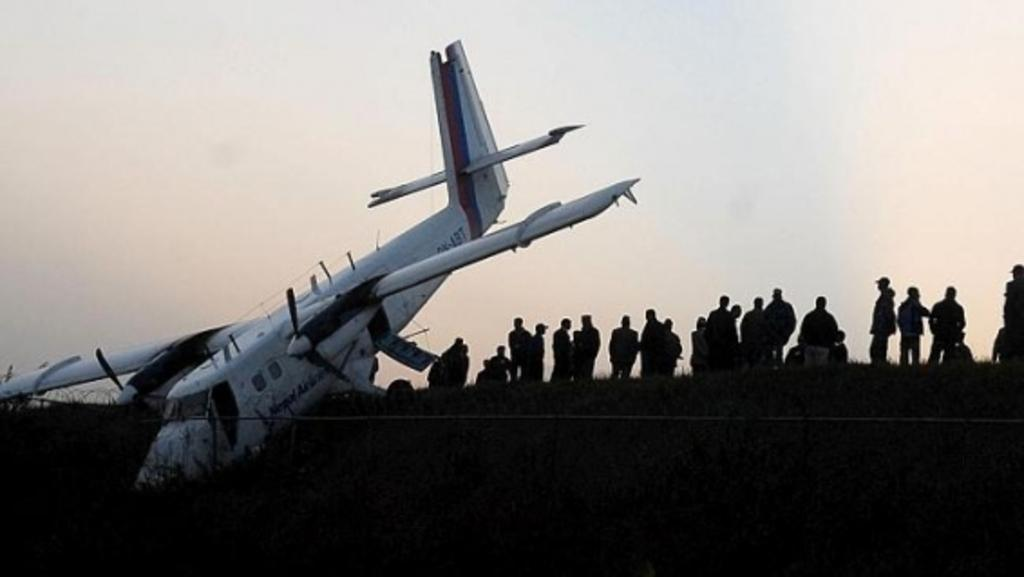What is the main subject of the image? The main subject of the image is an aircraft. What is the condition of the aircraft in the image? The aircraft appears to be crashed. Are there any people present in the image? Yes, there are people standing near the crashed aircraft. What is visible in the background of the image? The sky is visible in the image. What type of knowledge can be seen growing from the seed in the image? There is no seed or knowledge present in the image; it features a crashed aircraft and people standing nearby. 